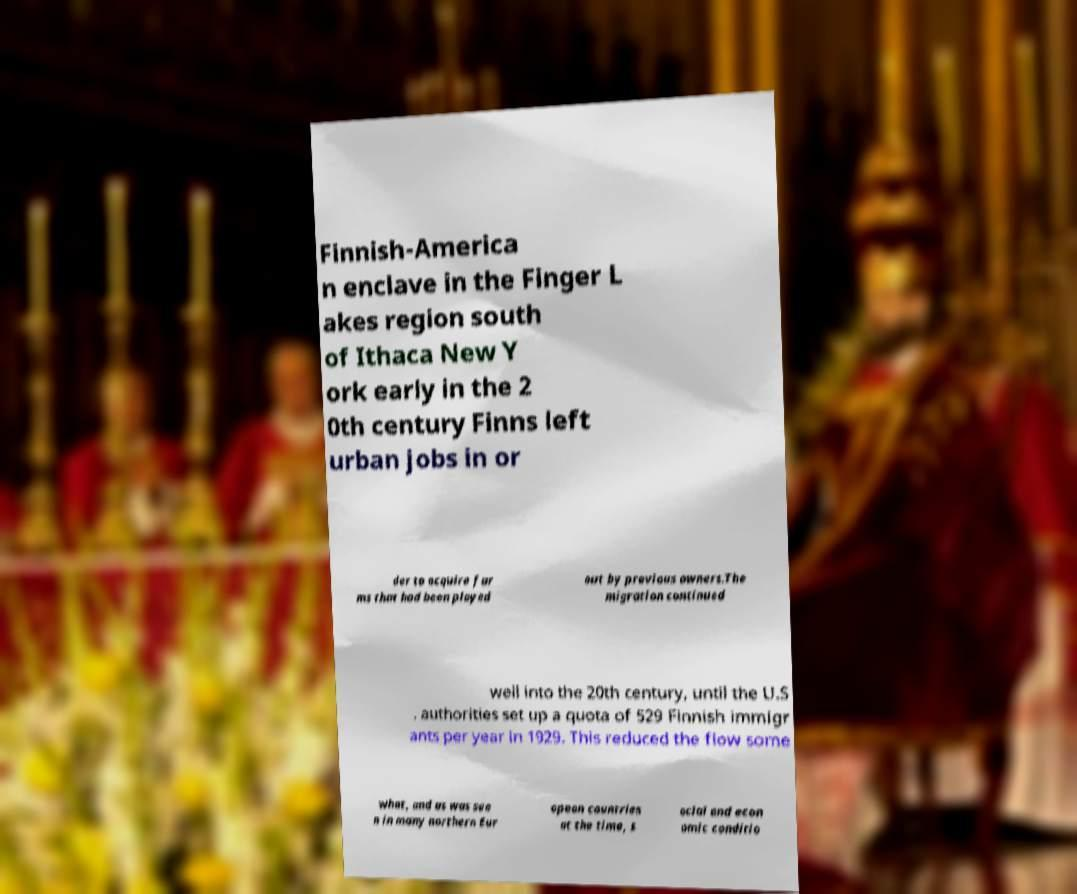There's text embedded in this image that I need extracted. Can you transcribe it verbatim? Finnish-America n enclave in the Finger L akes region south of Ithaca New Y ork early in the 2 0th century Finns left urban jobs in or der to acquire far ms that had been played out by previous owners.The migration continued well into the 20th century, until the U.S . authorities set up a quota of 529 Finnish immigr ants per year in 1929. This reduced the flow some what, and as was see n in many northern Eur opean countries at the time, s ocial and econ omic conditio 